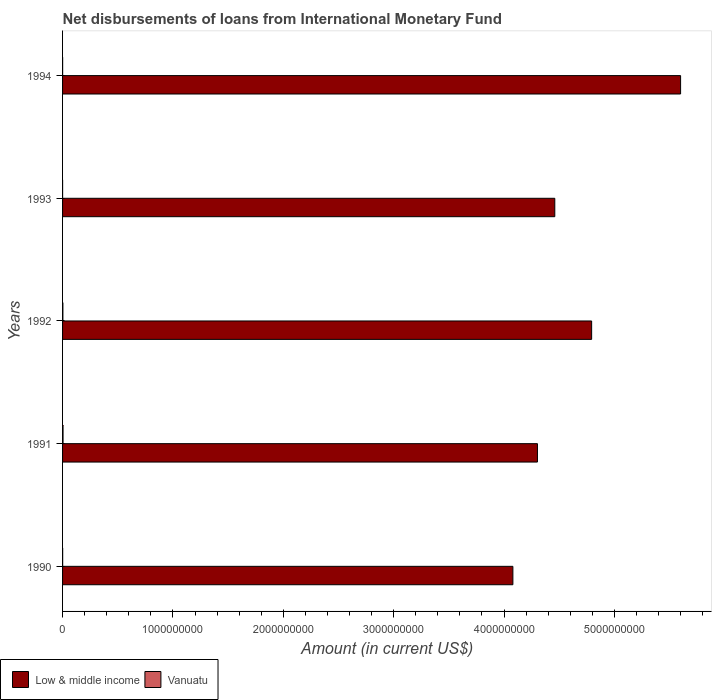Are the number of bars on each tick of the Y-axis equal?
Your answer should be very brief. Yes. How many bars are there on the 3rd tick from the top?
Keep it short and to the point. 2. What is the label of the 5th group of bars from the top?
Provide a short and direct response. 1990. What is the amount of loans disbursed in Vanuatu in 1992?
Ensure brevity in your answer.  2.99e+06. Across all years, what is the maximum amount of loans disbursed in Low & middle income?
Provide a short and direct response. 5.60e+09. Across all years, what is the minimum amount of loans disbursed in Vanuatu?
Your response must be concise. 2.56e+05. In which year was the amount of loans disbursed in Low & middle income maximum?
Your response must be concise. 1994. What is the total amount of loans disbursed in Vanuatu in the graph?
Offer a terse response. 8.88e+06. What is the difference between the amount of loans disbursed in Vanuatu in 1992 and that in 1994?
Make the answer very short. 2.49e+06. What is the difference between the amount of loans disbursed in Vanuatu in 1993 and the amount of loans disbursed in Low & middle income in 1991?
Provide a short and direct response. -4.30e+09. What is the average amount of loans disbursed in Vanuatu per year?
Give a very brief answer. 1.78e+06. In the year 1990, what is the difference between the amount of loans disbursed in Low & middle income and amount of loans disbursed in Vanuatu?
Your answer should be very brief. 4.08e+09. What is the ratio of the amount of loans disbursed in Low & middle income in 1990 to that in 1992?
Your answer should be compact. 0.85. Is the amount of loans disbursed in Vanuatu in 1990 less than that in 1994?
Offer a terse response. No. Is the difference between the amount of loans disbursed in Low & middle income in 1990 and 1991 greater than the difference between the amount of loans disbursed in Vanuatu in 1990 and 1991?
Your answer should be compact. No. What is the difference between the highest and the second highest amount of loans disbursed in Vanuatu?
Make the answer very short. 1.34e+06. What is the difference between the highest and the lowest amount of loans disbursed in Vanuatu?
Ensure brevity in your answer.  4.08e+06. In how many years, is the amount of loans disbursed in Vanuatu greater than the average amount of loans disbursed in Vanuatu taken over all years?
Make the answer very short. 2. Is the sum of the amount of loans disbursed in Vanuatu in 1991 and 1994 greater than the maximum amount of loans disbursed in Low & middle income across all years?
Your response must be concise. No. How many bars are there?
Give a very brief answer. 10. Are all the bars in the graph horizontal?
Give a very brief answer. Yes. What is the difference between two consecutive major ticks on the X-axis?
Ensure brevity in your answer.  1.00e+09. Are the values on the major ticks of X-axis written in scientific E-notation?
Make the answer very short. No. How many legend labels are there?
Offer a terse response. 2. How are the legend labels stacked?
Ensure brevity in your answer.  Horizontal. What is the title of the graph?
Offer a very short reply. Net disbursements of loans from International Monetary Fund. Does "Tuvalu" appear as one of the legend labels in the graph?
Make the answer very short. No. What is the label or title of the Y-axis?
Offer a very short reply. Years. What is the Amount (in current US$) in Low & middle income in 1990?
Make the answer very short. 4.08e+09. What is the Amount (in current US$) of Vanuatu in 1990?
Your answer should be compact. 8.09e+05. What is the Amount (in current US$) of Low & middle income in 1991?
Provide a succinct answer. 4.30e+09. What is the Amount (in current US$) in Vanuatu in 1991?
Provide a short and direct response. 4.33e+06. What is the Amount (in current US$) in Low & middle income in 1992?
Offer a terse response. 4.79e+09. What is the Amount (in current US$) of Vanuatu in 1992?
Offer a very short reply. 2.99e+06. What is the Amount (in current US$) of Low & middle income in 1993?
Ensure brevity in your answer.  4.46e+09. What is the Amount (in current US$) in Vanuatu in 1993?
Make the answer very short. 2.56e+05. What is the Amount (in current US$) in Low & middle income in 1994?
Your response must be concise. 5.60e+09. What is the Amount (in current US$) of Vanuatu in 1994?
Offer a very short reply. 4.99e+05. Across all years, what is the maximum Amount (in current US$) of Low & middle income?
Your answer should be compact. 5.60e+09. Across all years, what is the maximum Amount (in current US$) in Vanuatu?
Your answer should be very brief. 4.33e+06. Across all years, what is the minimum Amount (in current US$) of Low & middle income?
Keep it short and to the point. 4.08e+09. Across all years, what is the minimum Amount (in current US$) of Vanuatu?
Provide a succinct answer. 2.56e+05. What is the total Amount (in current US$) in Low & middle income in the graph?
Ensure brevity in your answer.  2.32e+1. What is the total Amount (in current US$) in Vanuatu in the graph?
Ensure brevity in your answer.  8.88e+06. What is the difference between the Amount (in current US$) of Low & middle income in 1990 and that in 1991?
Your answer should be very brief. -2.23e+08. What is the difference between the Amount (in current US$) of Vanuatu in 1990 and that in 1991?
Make the answer very short. -3.52e+06. What is the difference between the Amount (in current US$) of Low & middle income in 1990 and that in 1992?
Provide a succinct answer. -7.14e+08. What is the difference between the Amount (in current US$) of Vanuatu in 1990 and that in 1992?
Make the answer very short. -2.18e+06. What is the difference between the Amount (in current US$) of Low & middle income in 1990 and that in 1993?
Give a very brief answer. -3.80e+08. What is the difference between the Amount (in current US$) in Vanuatu in 1990 and that in 1993?
Offer a terse response. 5.53e+05. What is the difference between the Amount (in current US$) of Low & middle income in 1990 and that in 1994?
Provide a short and direct response. -1.52e+09. What is the difference between the Amount (in current US$) of Vanuatu in 1990 and that in 1994?
Give a very brief answer. 3.10e+05. What is the difference between the Amount (in current US$) in Low & middle income in 1991 and that in 1992?
Offer a terse response. -4.91e+08. What is the difference between the Amount (in current US$) in Vanuatu in 1991 and that in 1992?
Make the answer very short. 1.34e+06. What is the difference between the Amount (in current US$) in Low & middle income in 1991 and that in 1993?
Ensure brevity in your answer.  -1.57e+08. What is the difference between the Amount (in current US$) in Vanuatu in 1991 and that in 1993?
Your response must be concise. 4.08e+06. What is the difference between the Amount (in current US$) in Low & middle income in 1991 and that in 1994?
Provide a short and direct response. -1.30e+09. What is the difference between the Amount (in current US$) in Vanuatu in 1991 and that in 1994?
Your answer should be compact. 3.83e+06. What is the difference between the Amount (in current US$) in Low & middle income in 1992 and that in 1993?
Provide a succinct answer. 3.34e+08. What is the difference between the Amount (in current US$) of Vanuatu in 1992 and that in 1993?
Keep it short and to the point. 2.73e+06. What is the difference between the Amount (in current US$) in Low & middle income in 1992 and that in 1994?
Give a very brief answer. -8.06e+08. What is the difference between the Amount (in current US$) in Vanuatu in 1992 and that in 1994?
Give a very brief answer. 2.49e+06. What is the difference between the Amount (in current US$) in Low & middle income in 1993 and that in 1994?
Ensure brevity in your answer.  -1.14e+09. What is the difference between the Amount (in current US$) of Vanuatu in 1993 and that in 1994?
Give a very brief answer. -2.43e+05. What is the difference between the Amount (in current US$) in Low & middle income in 1990 and the Amount (in current US$) in Vanuatu in 1991?
Provide a succinct answer. 4.08e+09. What is the difference between the Amount (in current US$) in Low & middle income in 1990 and the Amount (in current US$) in Vanuatu in 1992?
Provide a succinct answer. 4.08e+09. What is the difference between the Amount (in current US$) of Low & middle income in 1990 and the Amount (in current US$) of Vanuatu in 1993?
Your response must be concise. 4.08e+09. What is the difference between the Amount (in current US$) of Low & middle income in 1990 and the Amount (in current US$) of Vanuatu in 1994?
Make the answer very short. 4.08e+09. What is the difference between the Amount (in current US$) in Low & middle income in 1991 and the Amount (in current US$) in Vanuatu in 1992?
Your answer should be compact. 4.30e+09. What is the difference between the Amount (in current US$) of Low & middle income in 1991 and the Amount (in current US$) of Vanuatu in 1993?
Your response must be concise. 4.30e+09. What is the difference between the Amount (in current US$) in Low & middle income in 1991 and the Amount (in current US$) in Vanuatu in 1994?
Offer a terse response. 4.30e+09. What is the difference between the Amount (in current US$) of Low & middle income in 1992 and the Amount (in current US$) of Vanuatu in 1993?
Your response must be concise. 4.79e+09. What is the difference between the Amount (in current US$) of Low & middle income in 1992 and the Amount (in current US$) of Vanuatu in 1994?
Your answer should be very brief. 4.79e+09. What is the difference between the Amount (in current US$) in Low & middle income in 1993 and the Amount (in current US$) in Vanuatu in 1994?
Offer a very short reply. 4.46e+09. What is the average Amount (in current US$) in Low & middle income per year?
Your answer should be compact. 4.65e+09. What is the average Amount (in current US$) of Vanuatu per year?
Provide a short and direct response. 1.78e+06. In the year 1990, what is the difference between the Amount (in current US$) of Low & middle income and Amount (in current US$) of Vanuatu?
Offer a terse response. 4.08e+09. In the year 1991, what is the difference between the Amount (in current US$) in Low & middle income and Amount (in current US$) in Vanuatu?
Ensure brevity in your answer.  4.30e+09. In the year 1992, what is the difference between the Amount (in current US$) of Low & middle income and Amount (in current US$) of Vanuatu?
Offer a terse response. 4.79e+09. In the year 1993, what is the difference between the Amount (in current US$) in Low & middle income and Amount (in current US$) in Vanuatu?
Provide a short and direct response. 4.46e+09. In the year 1994, what is the difference between the Amount (in current US$) in Low & middle income and Amount (in current US$) in Vanuatu?
Offer a terse response. 5.60e+09. What is the ratio of the Amount (in current US$) in Low & middle income in 1990 to that in 1991?
Your answer should be compact. 0.95. What is the ratio of the Amount (in current US$) of Vanuatu in 1990 to that in 1991?
Your answer should be compact. 0.19. What is the ratio of the Amount (in current US$) in Low & middle income in 1990 to that in 1992?
Offer a very short reply. 0.85. What is the ratio of the Amount (in current US$) in Vanuatu in 1990 to that in 1992?
Provide a succinct answer. 0.27. What is the ratio of the Amount (in current US$) of Low & middle income in 1990 to that in 1993?
Offer a terse response. 0.91. What is the ratio of the Amount (in current US$) in Vanuatu in 1990 to that in 1993?
Your response must be concise. 3.16. What is the ratio of the Amount (in current US$) of Low & middle income in 1990 to that in 1994?
Your answer should be compact. 0.73. What is the ratio of the Amount (in current US$) of Vanuatu in 1990 to that in 1994?
Provide a short and direct response. 1.62. What is the ratio of the Amount (in current US$) in Low & middle income in 1991 to that in 1992?
Ensure brevity in your answer.  0.9. What is the ratio of the Amount (in current US$) of Vanuatu in 1991 to that in 1992?
Ensure brevity in your answer.  1.45. What is the ratio of the Amount (in current US$) in Low & middle income in 1991 to that in 1993?
Your response must be concise. 0.96. What is the ratio of the Amount (in current US$) of Vanuatu in 1991 to that in 1993?
Keep it short and to the point. 16.92. What is the ratio of the Amount (in current US$) in Low & middle income in 1991 to that in 1994?
Offer a terse response. 0.77. What is the ratio of the Amount (in current US$) of Vanuatu in 1991 to that in 1994?
Offer a very short reply. 8.68. What is the ratio of the Amount (in current US$) in Low & middle income in 1992 to that in 1993?
Provide a succinct answer. 1.07. What is the ratio of the Amount (in current US$) of Vanuatu in 1992 to that in 1993?
Offer a very short reply. 11.67. What is the ratio of the Amount (in current US$) in Low & middle income in 1992 to that in 1994?
Give a very brief answer. 0.86. What is the ratio of the Amount (in current US$) in Vanuatu in 1992 to that in 1994?
Your answer should be compact. 5.99. What is the ratio of the Amount (in current US$) of Low & middle income in 1993 to that in 1994?
Offer a very short reply. 0.8. What is the ratio of the Amount (in current US$) in Vanuatu in 1993 to that in 1994?
Your answer should be compact. 0.51. What is the difference between the highest and the second highest Amount (in current US$) in Low & middle income?
Provide a succinct answer. 8.06e+08. What is the difference between the highest and the second highest Amount (in current US$) of Vanuatu?
Keep it short and to the point. 1.34e+06. What is the difference between the highest and the lowest Amount (in current US$) of Low & middle income?
Keep it short and to the point. 1.52e+09. What is the difference between the highest and the lowest Amount (in current US$) of Vanuatu?
Keep it short and to the point. 4.08e+06. 